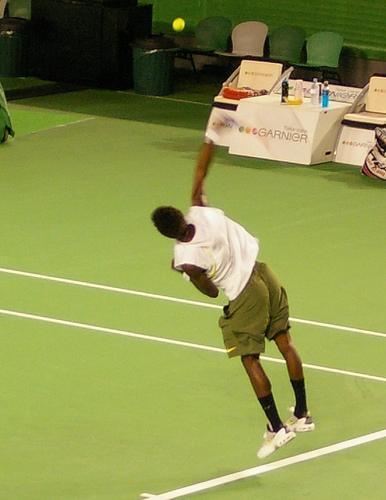How many elephants are in the picture?
Give a very brief answer. 0. 